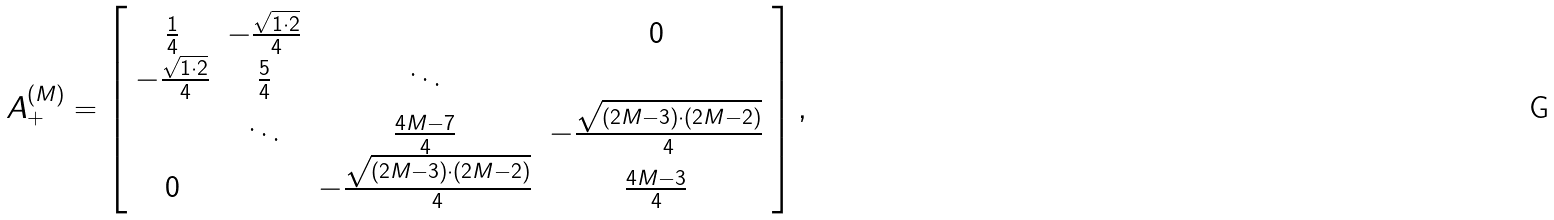<formula> <loc_0><loc_0><loc_500><loc_500>A ^ { ( M ) } _ { + } = \left [ \begin{array} { c c c c c c c } \frac { 1 } { 4 } & - \frac { \sqrt { 1 \cdot 2 } } { 4 } & & 0 \\ - \frac { \sqrt { 1 \cdot 2 } } { 4 } & \frac { 5 } { 4 } & \ddots & \\ & \ddots & \frac { 4 M - 7 } { 4 } & - \frac { \sqrt { ( 2 M - 3 ) \cdot ( 2 M - 2 ) } } { 4 } \\ 0 & & - \frac { \sqrt { ( 2 M - 3 ) \cdot ( 2 M - 2 ) } } { 4 } & \frac { 4 M - 3 } { 4 } \end{array} \right ] ,</formula> 